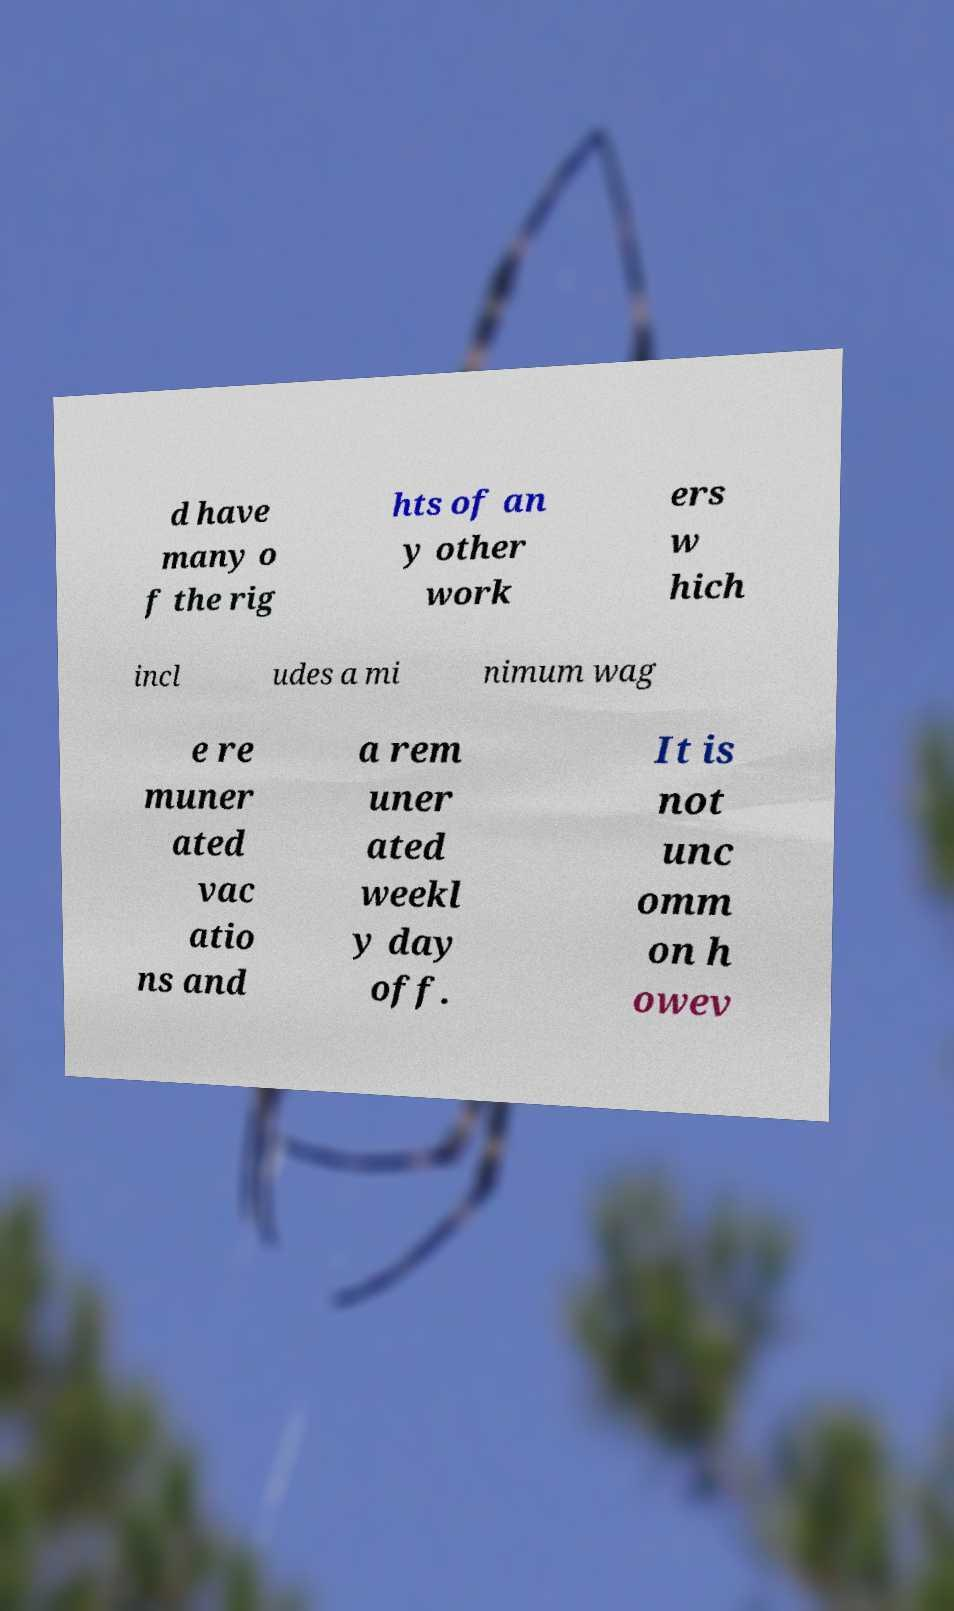Could you assist in decoding the text presented in this image and type it out clearly? d have many o f the rig hts of an y other work ers w hich incl udes a mi nimum wag e re muner ated vac atio ns and a rem uner ated weekl y day off. It is not unc omm on h owev 